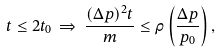Convert formula to latex. <formula><loc_0><loc_0><loc_500><loc_500>t \leq 2 t _ { 0 } \, \Rightarrow \, \frac { ( \Delta p ) ^ { 2 } t } { m } \leq \rho \left ( \frac { \Delta p } { p _ { 0 } } \right ) ,</formula> 